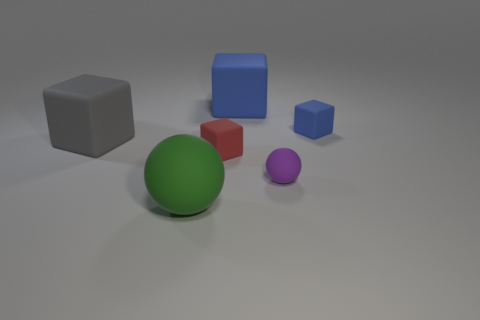Add 3 green balls. How many objects exist? 9 Subtract all cubes. How many objects are left? 2 Subtract all big gray rubber blocks. How many blocks are left? 3 Subtract 2 cubes. How many cubes are left? 2 Add 1 red matte objects. How many red matte objects are left? 2 Add 4 big blue blocks. How many big blue blocks exist? 5 Subtract all purple balls. How many balls are left? 1 Subtract 0 brown spheres. How many objects are left? 6 Subtract all red blocks. Subtract all purple balls. How many blocks are left? 3 Subtract all green cubes. How many purple balls are left? 1 